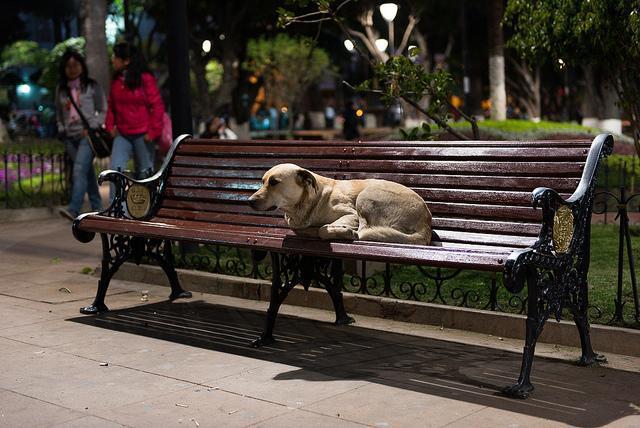How many people are in the photo?
Give a very brief answer. 2. How many motorcycles are on the road?
Give a very brief answer. 0. 